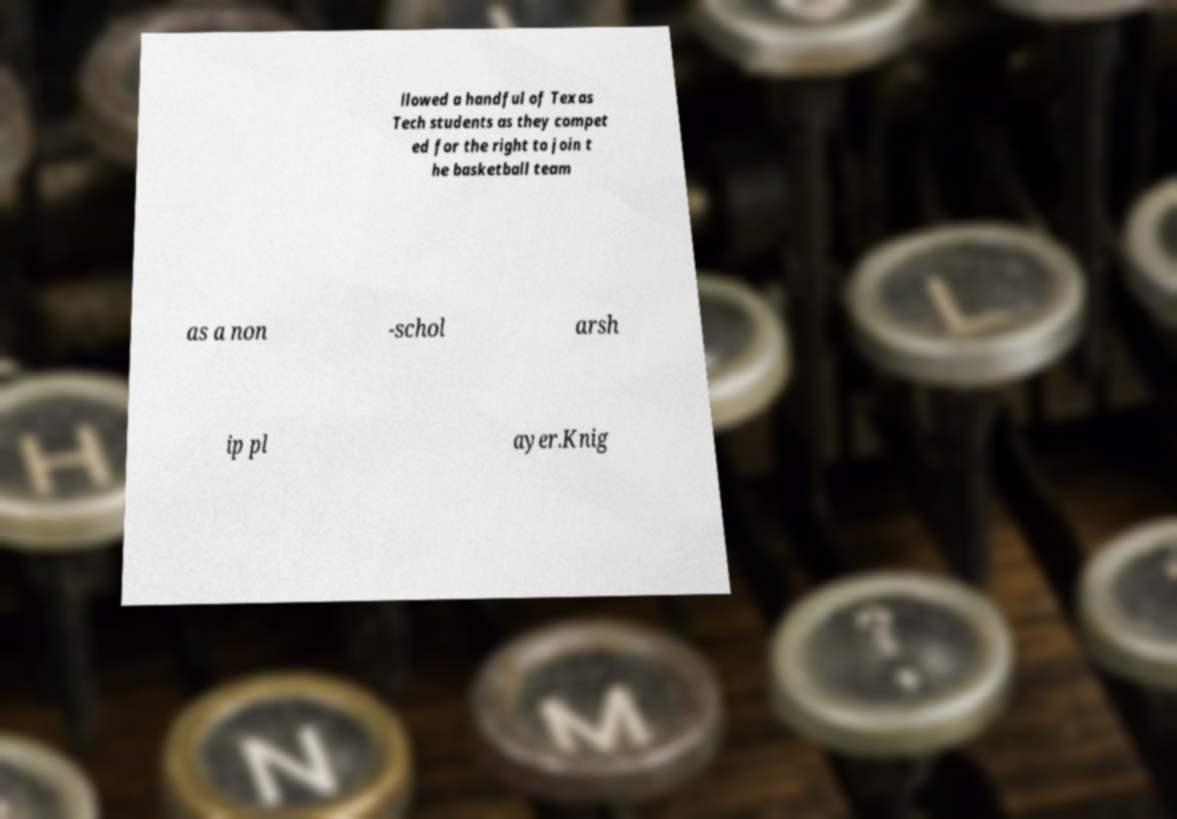Please read and relay the text visible in this image. What does it say? llowed a handful of Texas Tech students as they compet ed for the right to join t he basketball team as a non -schol arsh ip pl ayer.Knig 